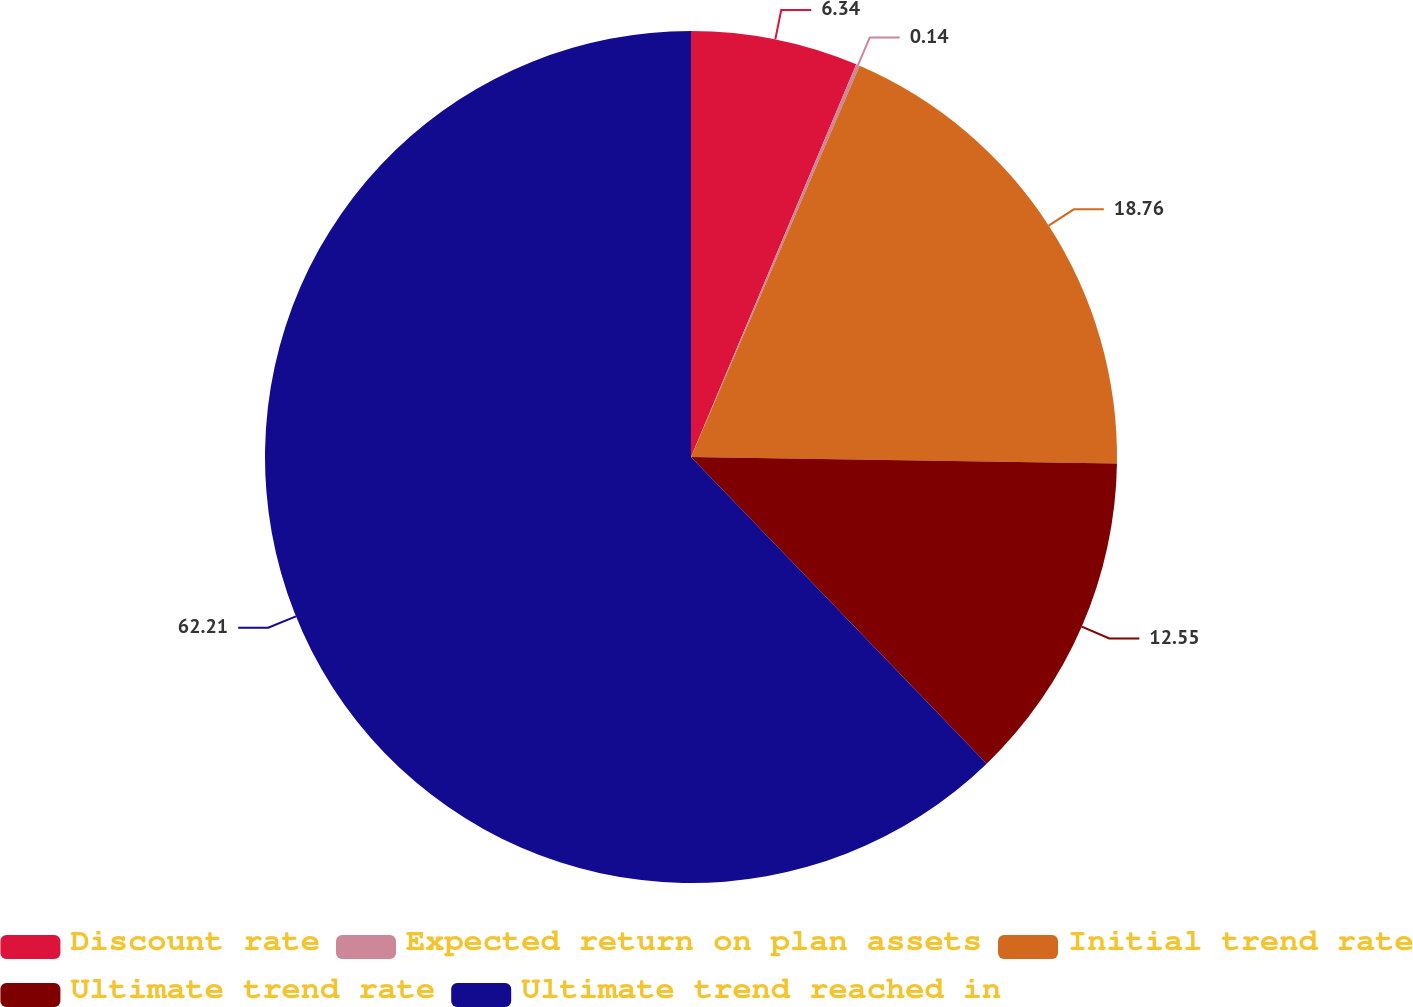Convert chart to OTSL. <chart><loc_0><loc_0><loc_500><loc_500><pie_chart><fcel>Discount rate<fcel>Expected return on plan assets<fcel>Initial trend rate<fcel>Ultimate trend rate<fcel>Ultimate trend reached in<nl><fcel>6.34%<fcel>0.14%<fcel>18.76%<fcel>12.55%<fcel>62.21%<nl></chart> 